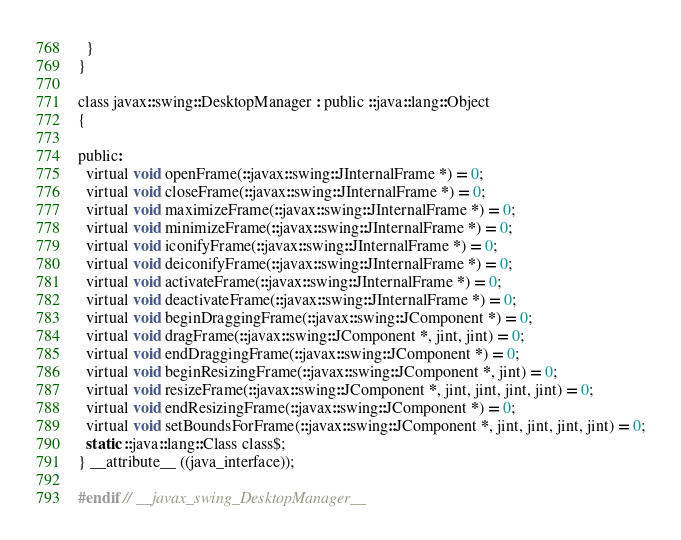Convert code to text. <code><loc_0><loc_0><loc_500><loc_500><_C_>  }
}

class javax::swing::DesktopManager : public ::java::lang::Object
{

public:
  virtual void openFrame(::javax::swing::JInternalFrame *) = 0;
  virtual void closeFrame(::javax::swing::JInternalFrame *) = 0;
  virtual void maximizeFrame(::javax::swing::JInternalFrame *) = 0;
  virtual void minimizeFrame(::javax::swing::JInternalFrame *) = 0;
  virtual void iconifyFrame(::javax::swing::JInternalFrame *) = 0;
  virtual void deiconifyFrame(::javax::swing::JInternalFrame *) = 0;
  virtual void activateFrame(::javax::swing::JInternalFrame *) = 0;
  virtual void deactivateFrame(::javax::swing::JInternalFrame *) = 0;
  virtual void beginDraggingFrame(::javax::swing::JComponent *) = 0;
  virtual void dragFrame(::javax::swing::JComponent *, jint, jint) = 0;
  virtual void endDraggingFrame(::javax::swing::JComponent *) = 0;
  virtual void beginResizingFrame(::javax::swing::JComponent *, jint) = 0;
  virtual void resizeFrame(::javax::swing::JComponent *, jint, jint, jint, jint) = 0;
  virtual void endResizingFrame(::javax::swing::JComponent *) = 0;
  virtual void setBoundsForFrame(::javax::swing::JComponent *, jint, jint, jint, jint) = 0;
  static ::java::lang::Class class$;
} __attribute__ ((java_interface));

#endif // __javax_swing_DesktopManager__
</code> 